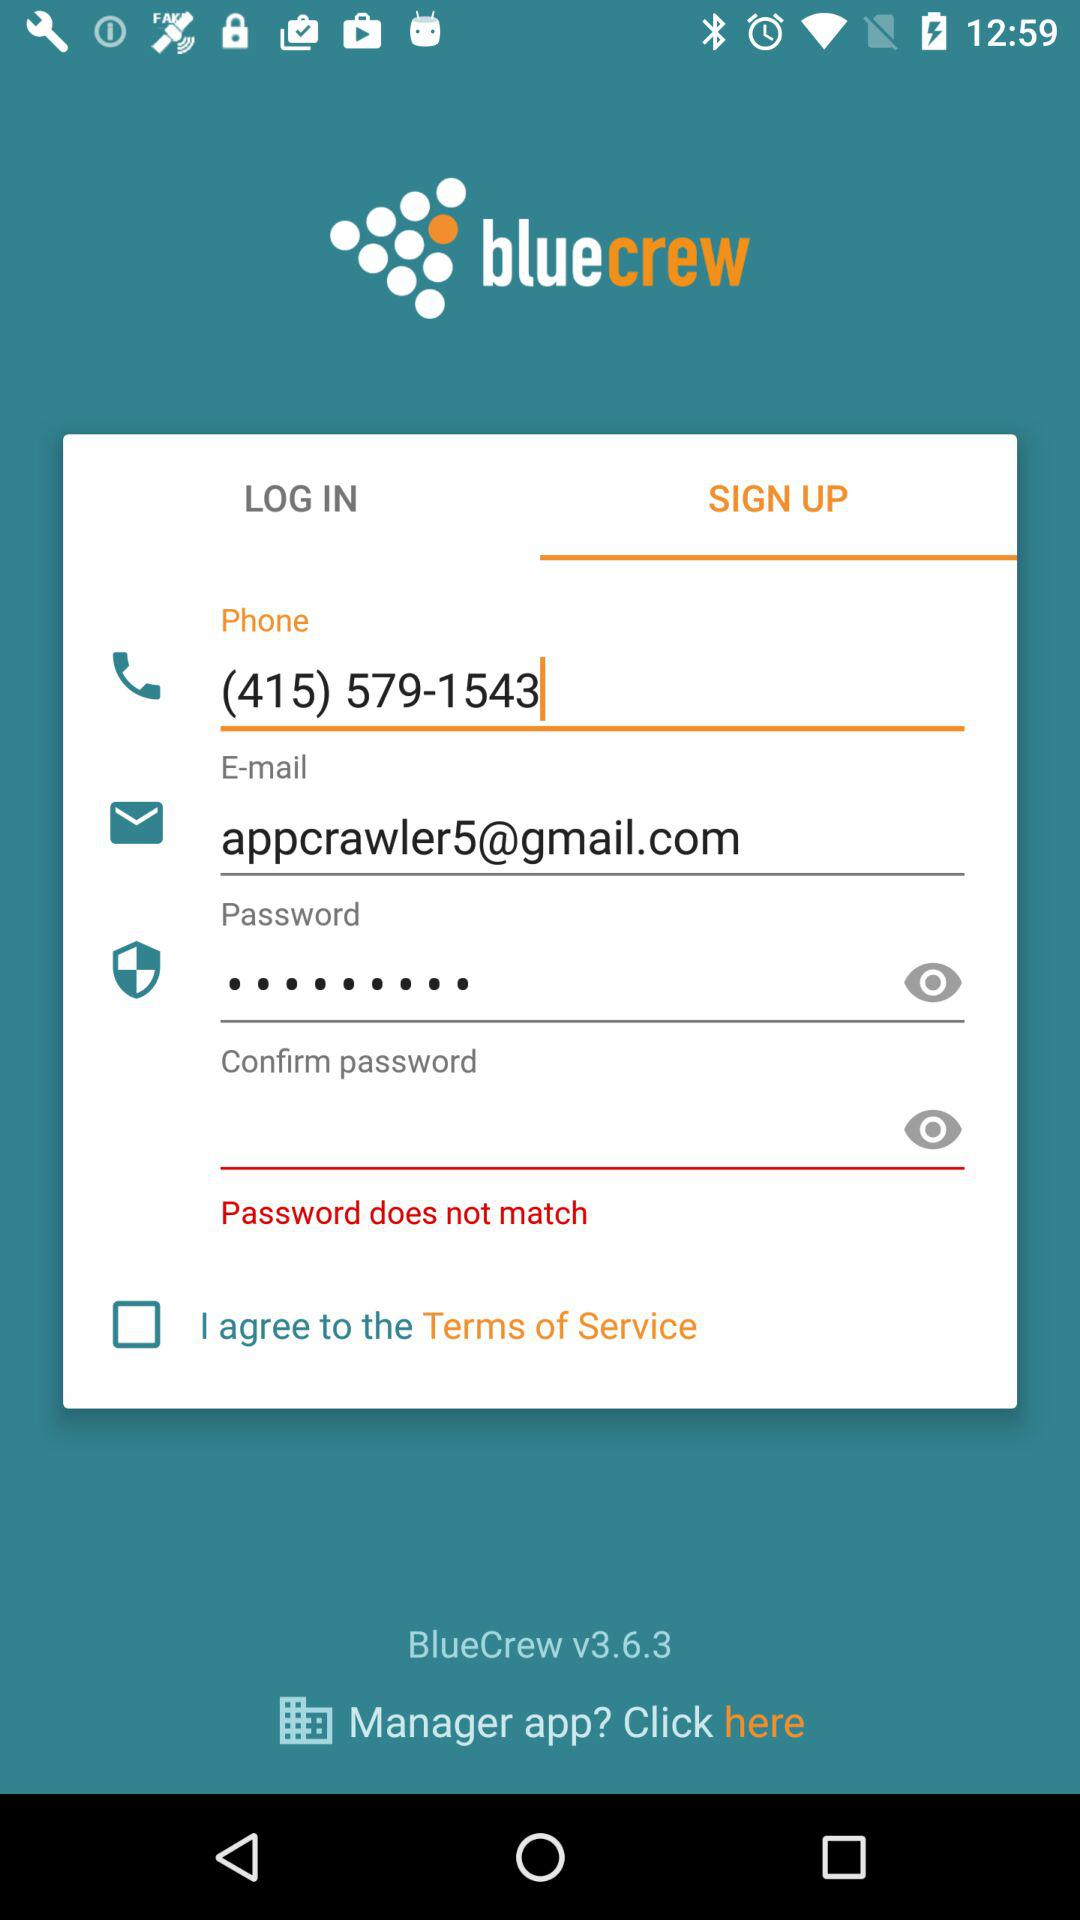What is the status of "I agree to the Terms of Service"? The status is "off". 